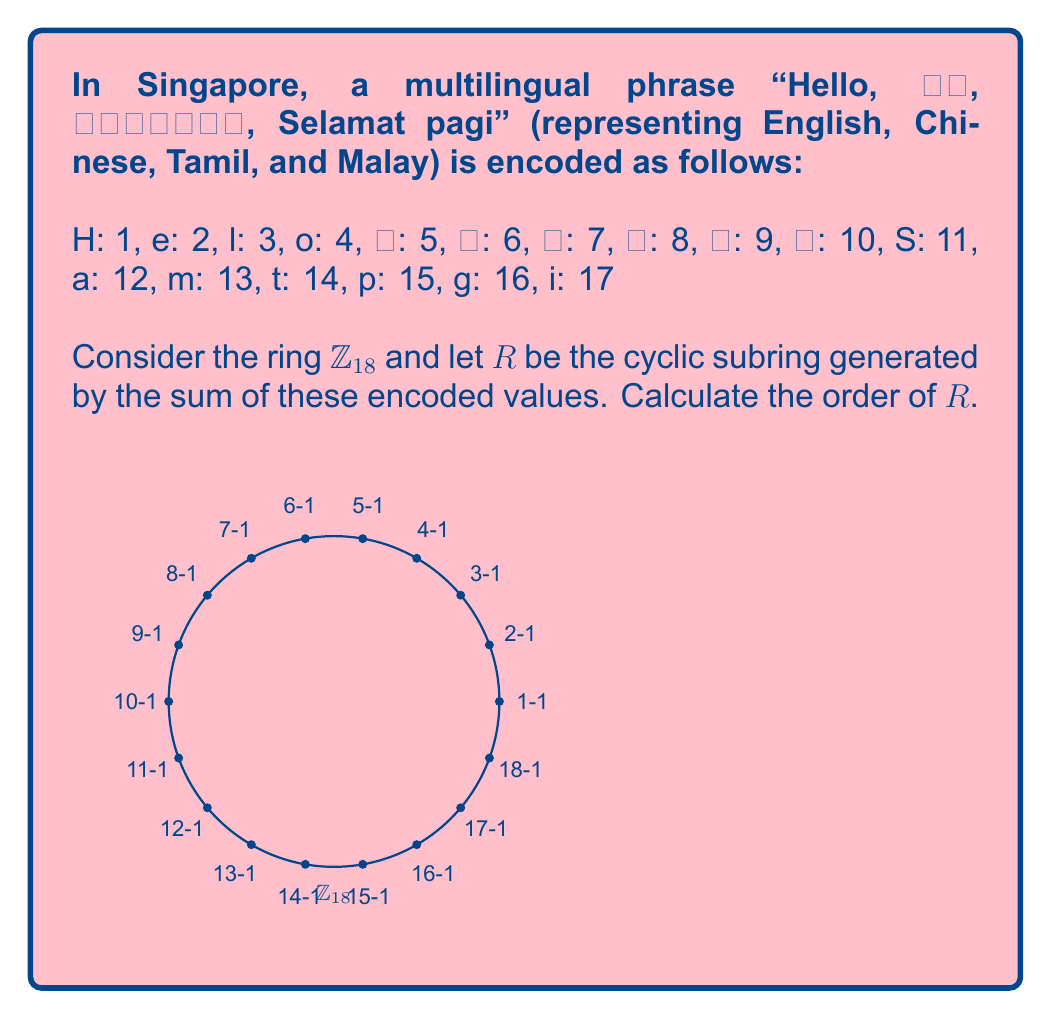Show me your answer to this math problem. Let's approach this step-by-step:

1) First, we need to calculate the sum of the encoded values:
   $1 + 2 + 3 + 3 + 4 + 5 + 6 + 7 + 8 + 9 + 10 + 11 + 2 + 3 + 12 + 13 + 12 + 14 + 15 + 12 + 16 + 17 = 185$

2) In $\mathbb{Z}_{18}$, this sum is equivalent to:
   $185 \equiv 5 \pmod{18}$

3) So, the cyclic subring $R$ is generated by the element 5 in $\mathbb{Z}_{18}$.

4) To find the order of $R$, we need to find the smallest positive integer $n$ such that:
   $5n \equiv 0 \pmod{18}$

5) Let's calculate the multiples of 5 in $\mathbb{Z}_{18}$:
   $5 \cdot 1 \equiv 5 \pmod{18}$
   $5 \cdot 2 \equiv 10 \pmod{18}$
   $5 \cdot 3 \equiv 15 \pmod{18}$
   $5 \cdot 4 \equiv 2 \pmod{18}$
   $5 \cdot 5 \equiv 7 \pmod{18}$
   $5 \cdot 6 \equiv 12 \pmod{18}$
   $5 \cdot 7 \equiv 17 \pmod{18}$
   $5 \cdot 8 \equiv 4 \pmod{18}$
   $5 \cdot 9 \equiv 9 \pmod{18}$
   $5 \cdot 10 \equiv 14 \pmod{18}$
   $5 \cdot 11 \equiv 1 \pmod{18}$
   $5 \cdot 12 \equiv 6 \pmod{18}$
   $5 \cdot 13 \equiv 11 \pmod{18}$
   $5 \cdot 14 \equiv 16 \pmod{18}$
   $5 \cdot 15 \equiv 3 \pmod{18}$
   $5 \cdot 16 \equiv 8 \pmod{18}$
   $5 \cdot 17 \equiv 13 \pmod{18}$
   $5 \cdot 18 \equiv 0 \pmod{18}$

6) We see that $5 \cdot 18 \equiv 0 \pmod{18}$, and this is the smallest positive integer that gives us 0.

Therefore, the order of the cyclic subring $R$ is 18.
Answer: 18 